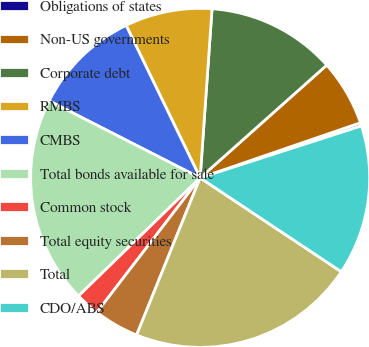Convert chart to OTSL. <chart><loc_0><loc_0><loc_500><loc_500><pie_chart><fcel>Obligations of states<fcel>Non-US governments<fcel>Corporate debt<fcel>RMBS<fcel>CMBS<fcel>Total bonds available for sale<fcel>Common stock<fcel>Total equity securities<fcel>Total<fcel>CDO/ABS<nl><fcel>0.31%<fcel>6.31%<fcel>12.3%<fcel>8.31%<fcel>10.3%<fcel>19.77%<fcel>2.31%<fcel>4.31%<fcel>21.77%<fcel>14.3%<nl></chart> 